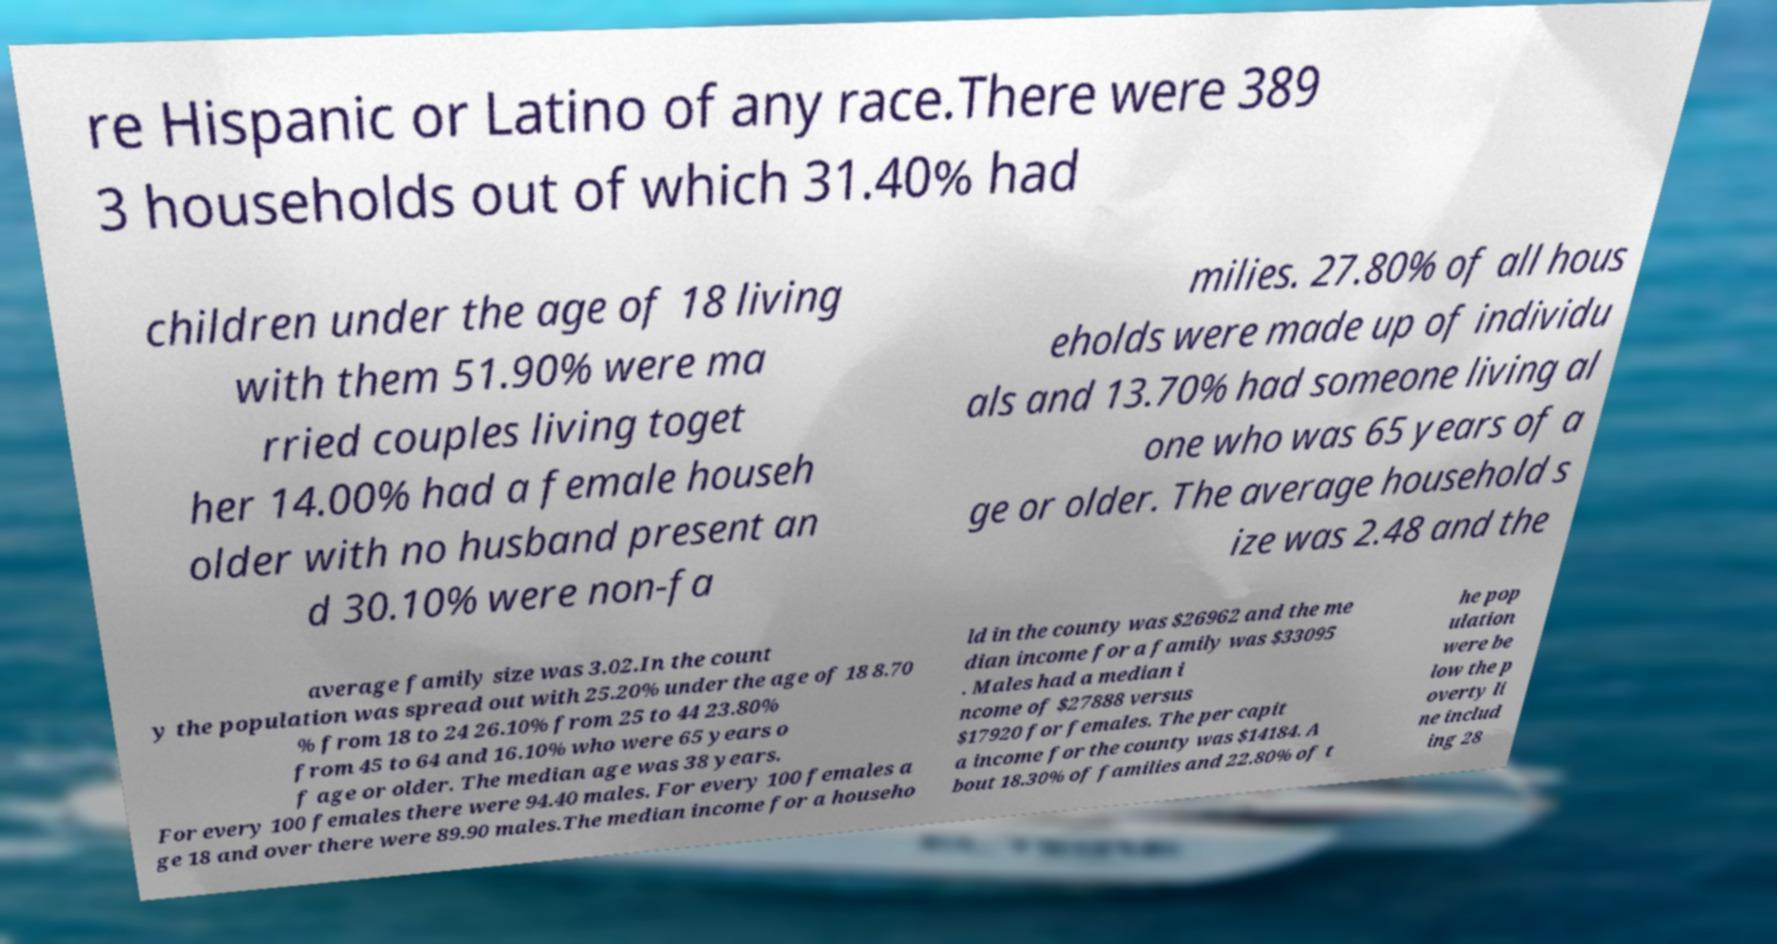Please identify and transcribe the text found in this image. re Hispanic or Latino of any race.There were 389 3 households out of which 31.40% had children under the age of 18 living with them 51.90% were ma rried couples living toget her 14.00% had a female househ older with no husband present an d 30.10% were non-fa milies. 27.80% of all hous eholds were made up of individu als and 13.70% had someone living al one who was 65 years of a ge or older. The average household s ize was 2.48 and the average family size was 3.02.In the count y the population was spread out with 25.20% under the age of 18 8.70 % from 18 to 24 26.10% from 25 to 44 23.80% from 45 to 64 and 16.10% who were 65 years o f age or older. The median age was 38 years. For every 100 females there were 94.40 males. For every 100 females a ge 18 and over there were 89.90 males.The median income for a househo ld in the county was $26962 and the me dian income for a family was $33095 . Males had a median i ncome of $27888 versus $17920 for females. The per capit a income for the county was $14184. A bout 18.30% of families and 22.80% of t he pop ulation were be low the p overty li ne includ ing 28 